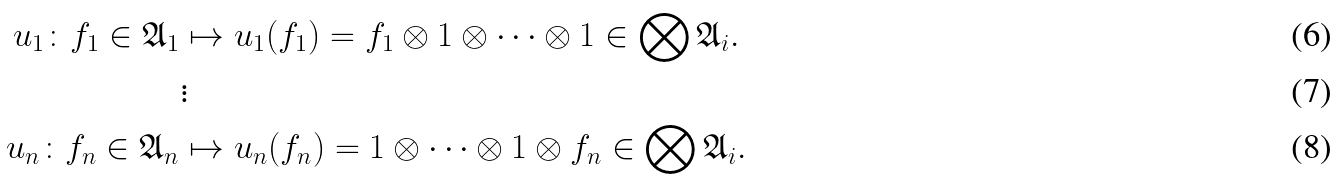Convert formula to latex. <formula><loc_0><loc_0><loc_500><loc_500>u _ { 1 } \colon f _ { 1 } \in \mathfrak { A } _ { 1 } & \mapsto u _ { 1 } ( f _ { 1 } ) = f _ { 1 } \otimes 1 \otimes \cdots \otimes 1 \in \bigotimes \mathfrak { A } _ { i } . \\ & \vdots \\ u _ { n } \colon f _ { n } \in \mathfrak { A } _ { n } & \mapsto u _ { n } ( f _ { n } ) = 1 \otimes \cdots \otimes 1 \otimes f _ { n } \in \bigotimes \mathfrak { A } _ { i } .</formula> 